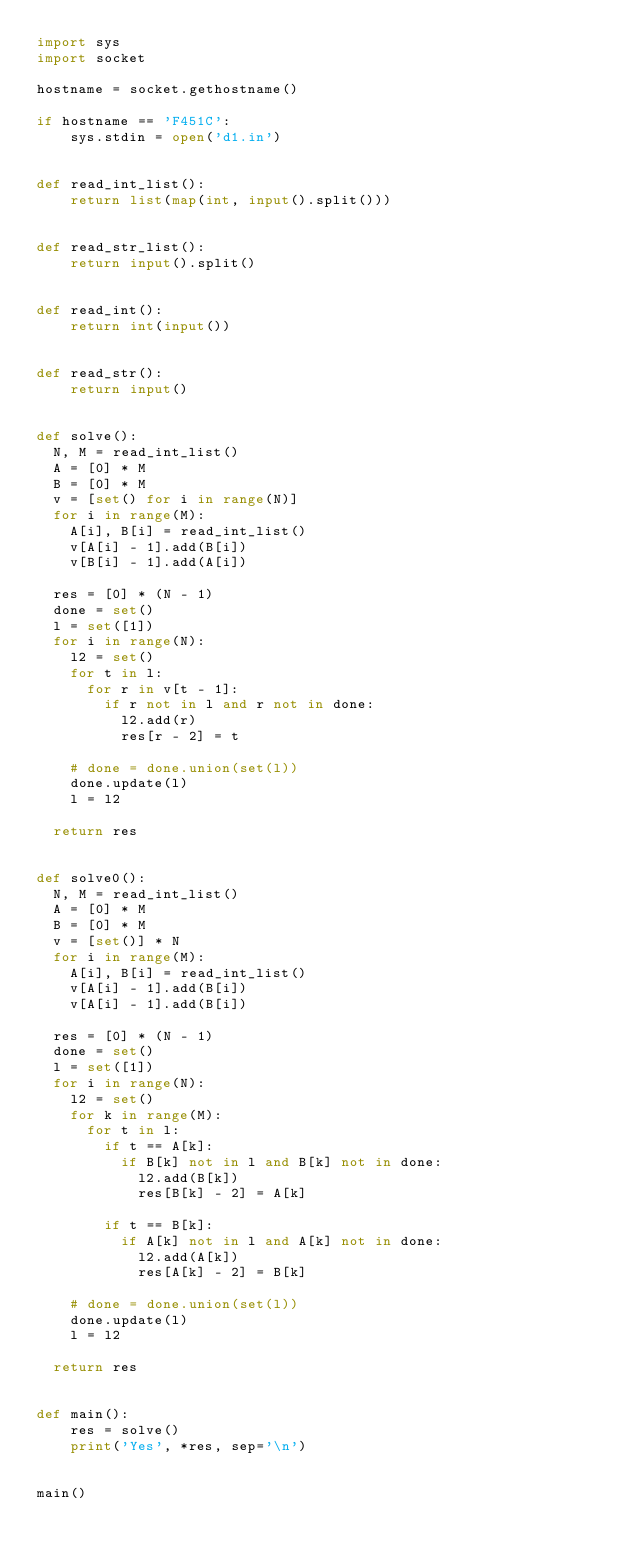Convert code to text. <code><loc_0><loc_0><loc_500><loc_500><_Python_>import sys
import socket

hostname = socket.gethostname()

if hostname == 'F451C':
    sys.stdin = open('d1.in')


def read_int_list():
    return list(map(int, input().split()))


def read_str_list():
    return input().split()


def read_int():
    return int(input())


def read_str():
    return input()


def solve():
  N, M = read_int_list()
  A = [0] * M
  B = [0] * M
  v = [set() for i in range(N)] 
  for i in range(M):
    A[i], B[i] = read_int_list()
    v[A[i] - 1].add(B[i])
    v[B[i] - 1].add(A[i])

  res = [0] * (N - 1)
  done = set()
  l = set([1])
  for i in range(N):
    l2 = set()
    for t in l:
      for r in v[t - 1]:
        if r not in l and r not in done:
          l2.add(r) 
          res[r - 2] = t

    # done = done.union(set(l))
    done.update(l)
    l = l2

  return res


def solve0():
  N, M = read_int_list()
  A = [0] * M
  B = [0] * M
  v = [set()] * N
  for i in range(M):
    A[i], B[i] = read_int_list()
    v[A[i] - 1].add(B[i])
    v[A[i] - 1].add(B[i])

  res = [0] * (N - 1)
  done = set()
  l = set([1])
  for i in range(N):
    l2 = set()
    for k in range(M):
      for t in l:
        if t == A[k]:
          if B[k] not in l and B[k] not in done:
            l2.add(B[k]) 
            res[B[k] - 2] = A[k]

        if t == B[k]:
          if A[k] not in l and A[k] not in done:
            l2.add(A[k])
            res[A[k] - 2] = B[k]

    # done = done.union(set(l))
    done.update(l)
    l = l2

  return res


def main():
    res = solve()
    print('Yes', *res, sep='\n')


main()
</code> 